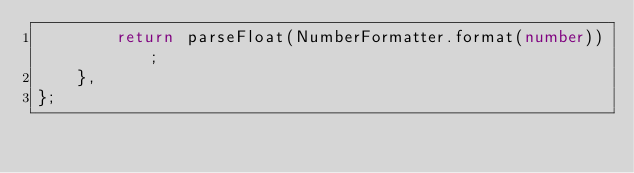<code> <loc_0><loc_0><loc_500><loc_500><_TypeScript_>        return parseFloat(NumberFormatter.format(number));
    },
};
</code> 